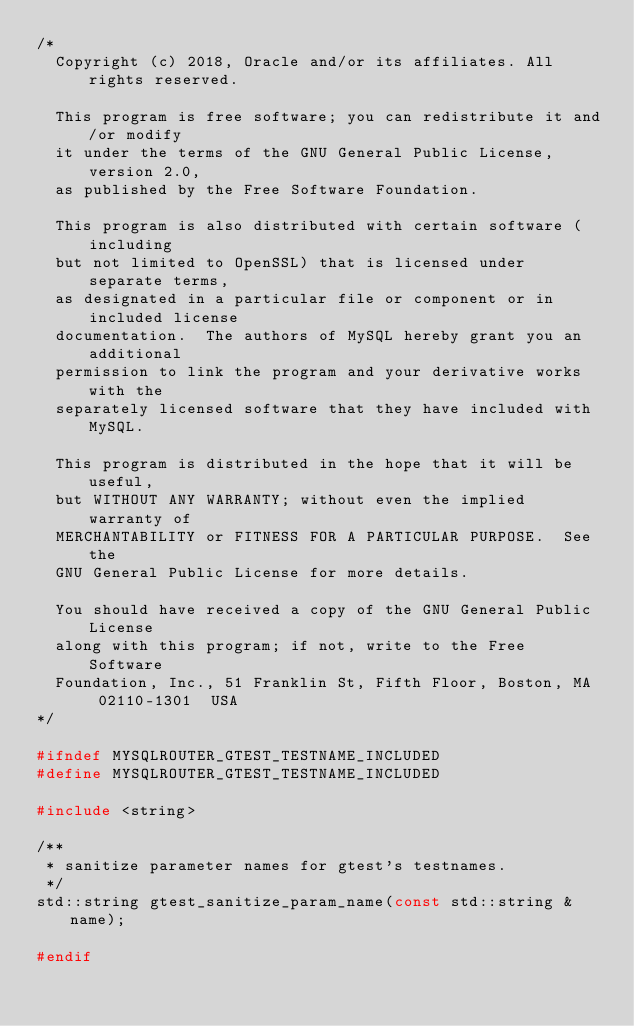Convert code to text. <code><loc_0><loc_0><loc_500><loc_500><_C_>/*
  Copyright (c) 2018, Oracle and/or its affiliates. All rights reserved.

  This program is free software; you can redistribute it and/or modify
  it under the terms of the GNU General Public License, version 2.0,
  as published by the Free Software Foundation.

  This program is also distributed with certain software (including
  but not limited to OpenSSL) that is licensed under separate terms,
  as designated in a particular file or component or in included license
  documentation.  The authors of MySQL hereby grant you an additional
  permission to link the program and your derivative works with the
  separately licensed software that they have included with MySQL.

  This program is distributed in the hope that it will be useful,
  but WITHOUT ANY WARRANTY; without even the implied warranty of
  MERCHANTABILITY or FITNESS FOR A PARTICULAR PURPOSE.  See the
  GNU General Public License for more details.

  You should have received a copy of the GNU General Public License
  along with this program; if not, write to the Free Software
  Foundation, Inc., 51 Franklin St, Fifth Floor, Boston, MA  02110-1301  USA
*/

#ifndef MYSQLROUTER_GTEST_TESTNAME_INCLUDED
#define MYSQLROUTER_GTEST_TESTNAME_INCLUDED

#include <string>

/**
 * sanitize parameter names for gtest's testnames.
 */
std::string gtest_sanitize_param_name(const std::string &name);

#endif
</code> 